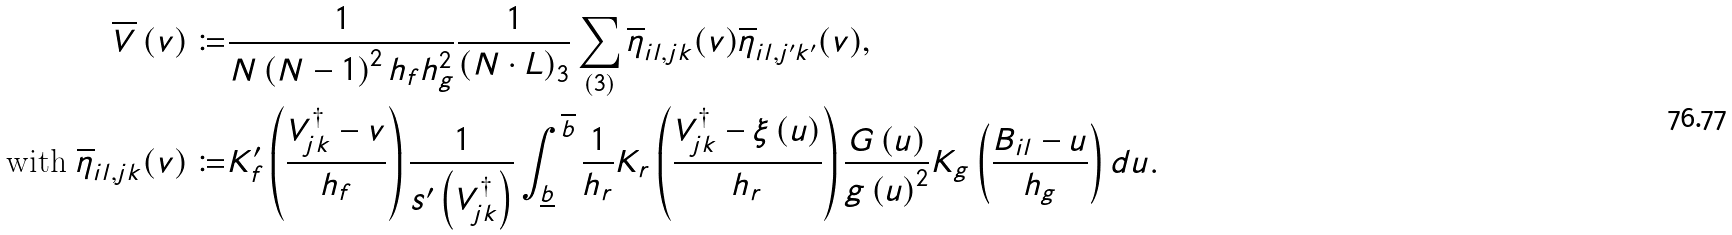<formula> <loc_0><loc_0><loc_500><loc_500>\overline { V } \left ( v \right ) \coloneqq & \frac { 1 } { N \left ( N - 1 \right ) ^ { 2 } h _ { f } h _ { g } ^ { 2 } } \frac { 1 } { \left ( N \cdot L \right ) _ { 3 } } \sum _ { \left ( 3 \right ) } \overline { \eta } _ { i l , j k } ( v ) \overline { \eta } _ { i l , j ^ { \prime } k ^ { \prime } } ( v ) , \\ \text {with } \overline { \eta } _ { i l , j k } ( v ) \coloneqq & K _ { f } ^ { \prime } \left ( \frac { V _ { j k } ^ { \dagger } - v } { h _ { f } } \right ) \frac { 1 } { s ^ { \prime } \left ( V _ { j k } ^ { \dagger } \right ) } \int _ { \underline { b } } ^ { \overline { b } } \frac { 1 } { h _ { r } } K _ { r } \left ( \frac { V _ { j k } ^ { \dagger } - \xi \left ( u \right ) } { h _ { r } } \right ) \frac { G \left ( u \right ) } { g \left ( u \right ) ^ { 2 } } K _ { g } \left ( \frac { B _ { i l } - u } { h _ { g } } \right ) d u .</formula> 